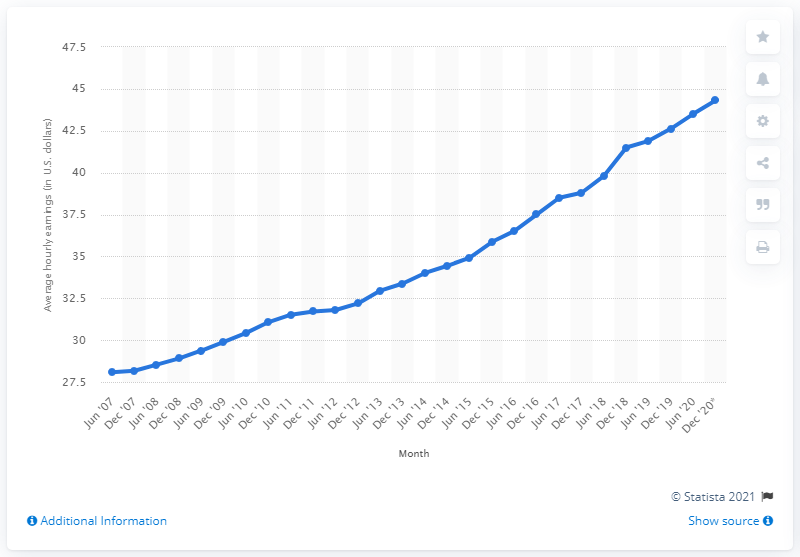Draw attention to some important aspects in this diagram. In June 2020, the average hourly earnings in the information sector was $43.51. 